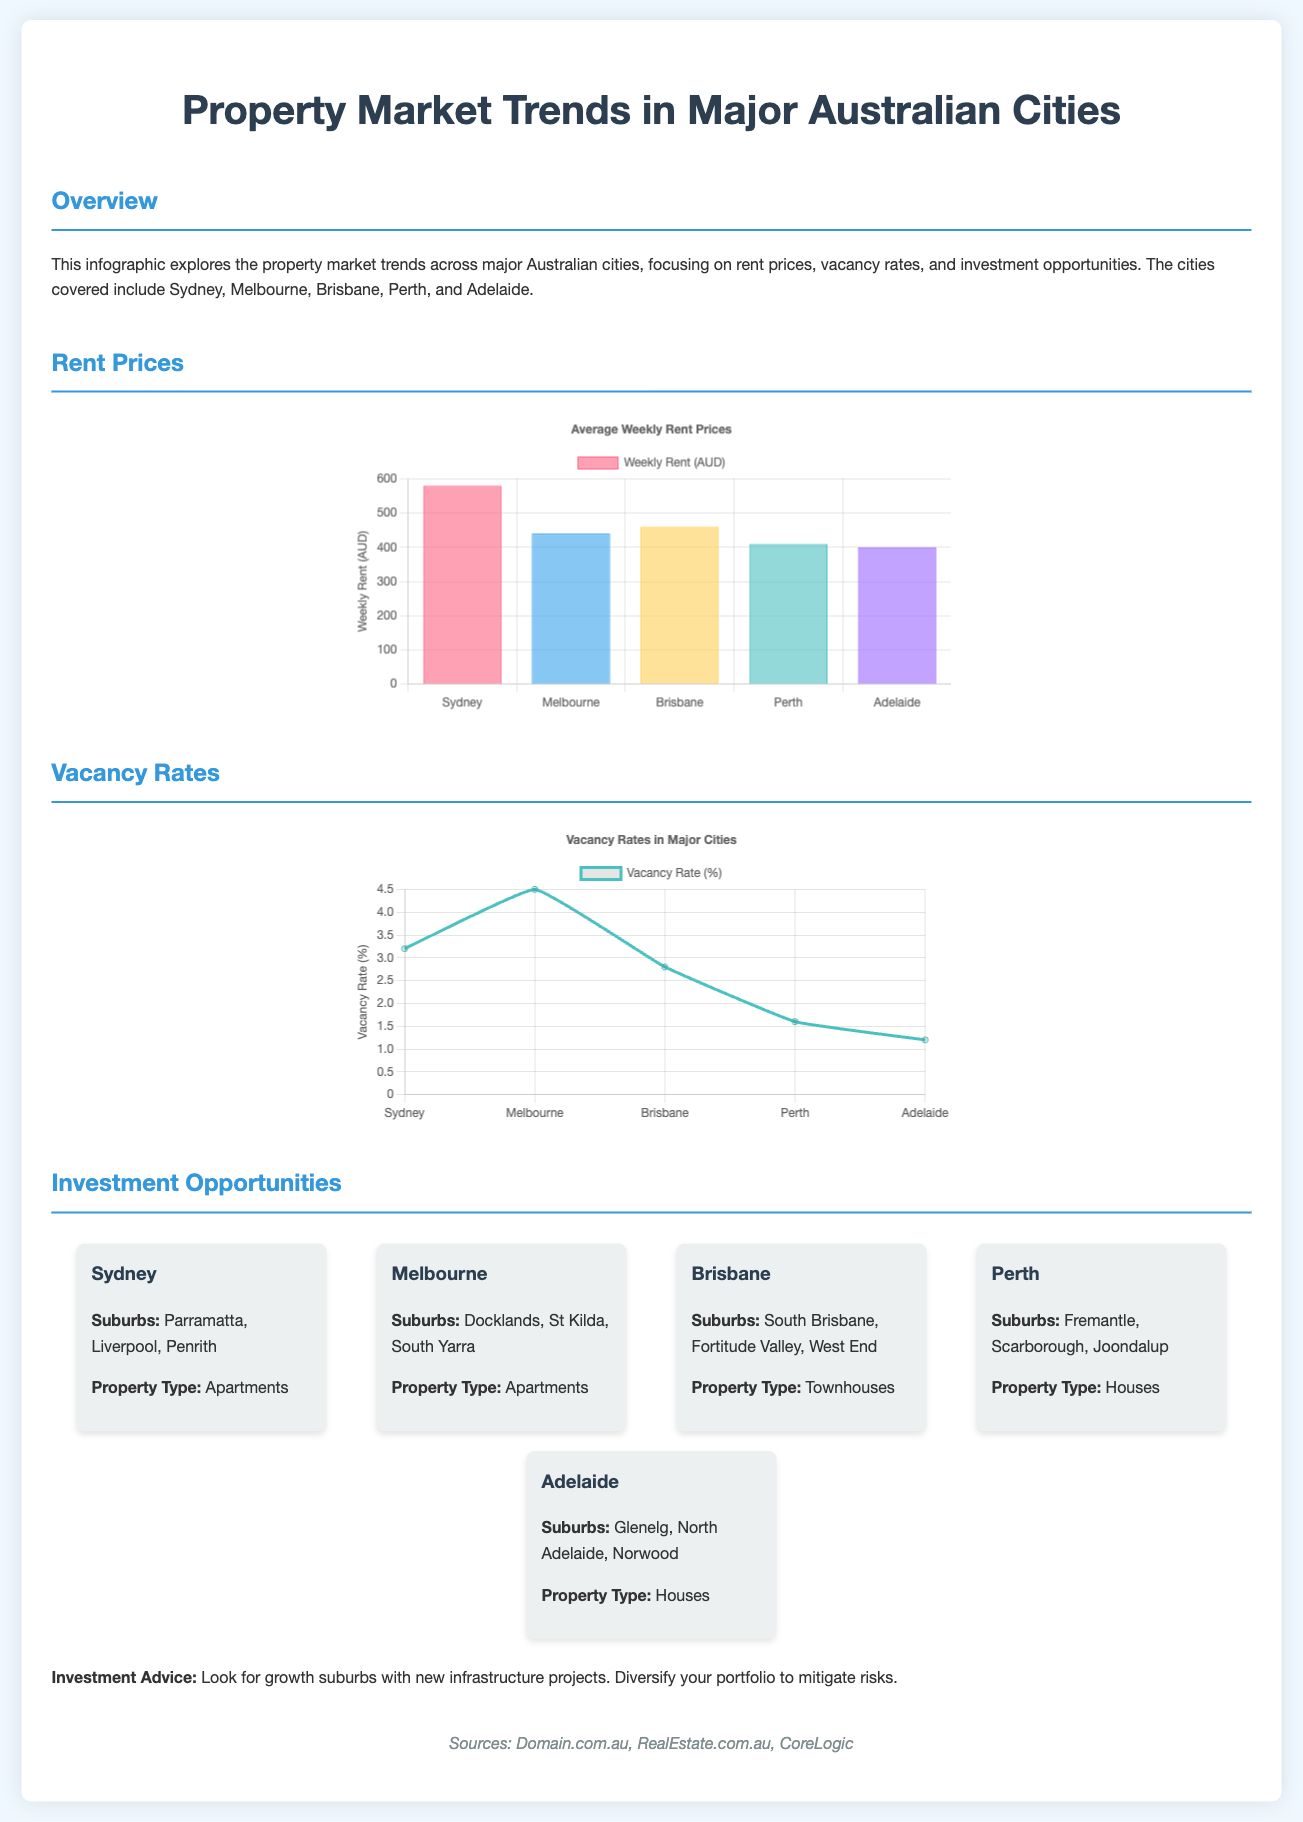What is the average weekly rent in Sydney? The average weekly rent in Sydney is clearly indicated in the rent chart of the document.
Answer: 580 Which city has the highest vacancy rate? The document states the vacancy rates in the chart, indicating each city's percentage.
Answer: Melbourne What property type is suggested for investment in Brisbane? The document lists the property types under investment opportunities for each city.
Answer: Townhouses What is the vacancy rate in Adelaide? The document provides specific vacancy rates for each city under the provided chart.
Answer: 1.2 Which suburb is mentioned for investment opportunities in Sydney? The investment opportunities section highlights specific suburbs for each city, including Sydney.
Answer: Parramatta What color represents the average weekly rent for Melbourne in the chart? The chart includes different colors for each city, clearly depicting their respective rents.
Answer: Blue What are two suburbs listed for investment in Melbourne? The investment opportunities provide a list of suburbs for each major city.
Answer: Docklands, St Kilda What is the average weekly rent in Perth? The rent prices can be found in the bar chart showing various cities' rents.
Answer: 410 Which city has the lowest vacancy rate? The vacancy rates are provided in a chart, allowing for a comparison among cities.
Answer: Perth 